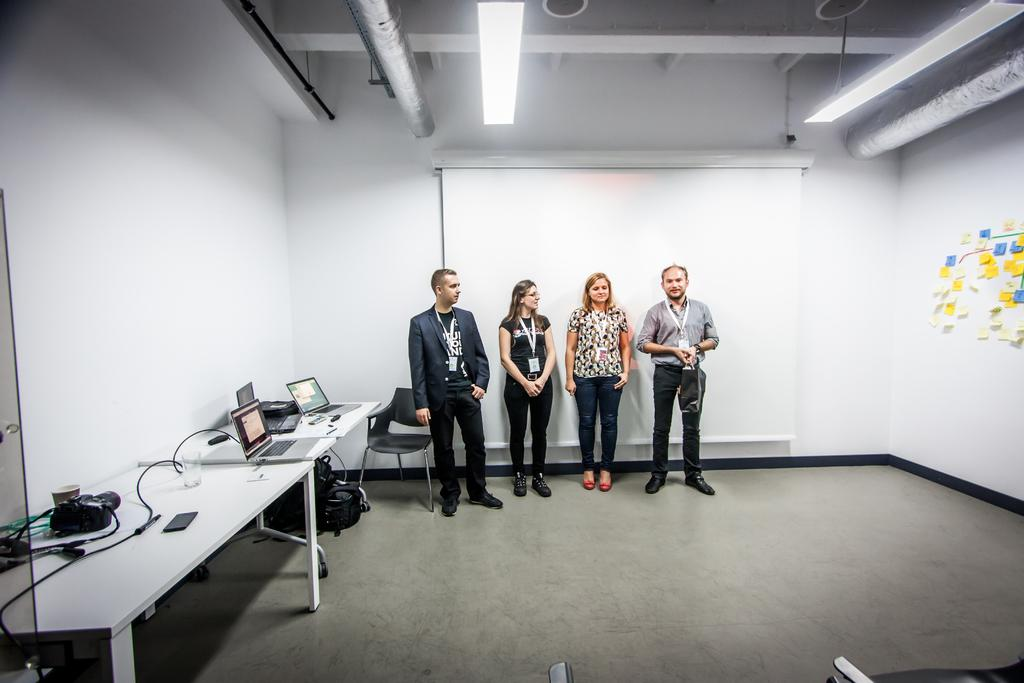How many people are present in the image? There are four people in the image. What objects are on the table in the image? There are laptops on a table in the image. Can you describe the lighting in the image? There is a light in the image. What is being projected onto the wall in the image? There is a projector projecting onto a wall in the image. What type of nest can be seen on the table in the image? There is no nest present in the image; the table contains laptops. Can you tell me how many bones are visible in the image? There are no bones visible in the image. 